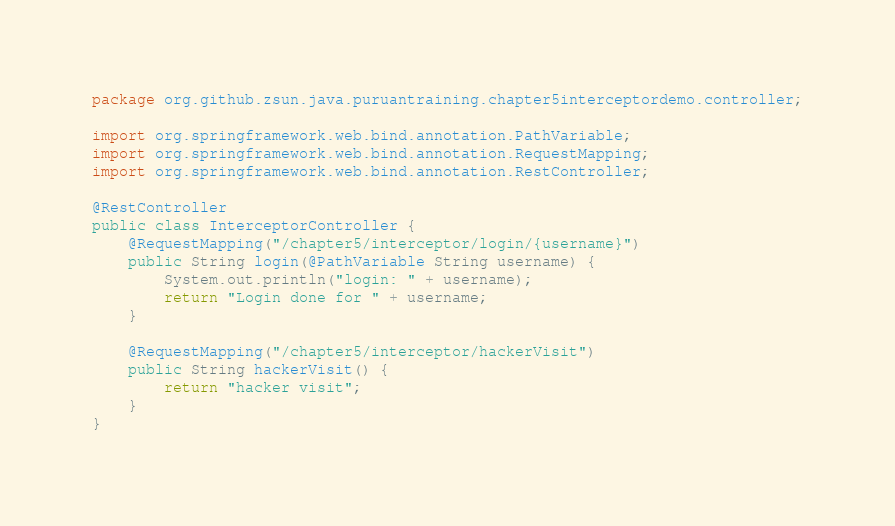Convert code to text. <code><loc_0><loc_0><loc_500><loc_500><_Java_>package org.github.zsun.java.puruantraining.chapter5interceptordemo.controller;

import org.springframework.web.bind.annotation.PathVariable;
import org.springframework.web.bind.annotation.RequestMapping;
import org.springframework.web.bind.annotation.RestController;

@RestController
public class InterceptorController {
    @RequestMapping("/chapter5/interceptor/login/{username}")
    public String login(@PathVariable String username) {
        System.out.println("login: " + username);
        return "Login done for " + username;
    }

    @RequestMapping("/chapter5/interceptor/hackerVisit")
    public String hackerVisit() {
        return "hacker visit";
    }
}
</code> 